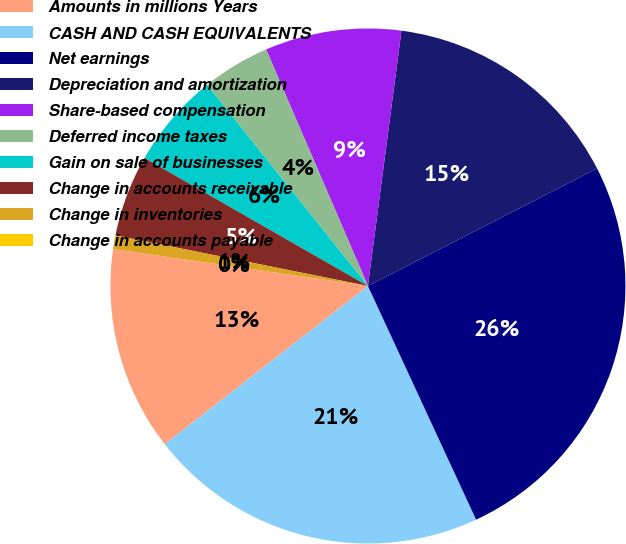Convert chart to OTSL. <chart><loc_0><loc_0><loc_500><loc_500><pie_chart><fcel>Amounts in millions Years<fcel>CASH AND CASH EQUIVALENTS<fcel>Net earnings<fcel>Depreciation and amortization<fcel>Share-based compensation<fcel>Deferred income taxes<fcel>Gain on sale of businesses<fcel>Change in accounts receivable<fcel>Change in inventories<fcel>Change in accounts payable<nl><fcel>12.82%<fcel>21.37%<fcel>25.64%<fcel>15.38%<fcel>8.55%<fcel>4.27%<fcel>5.98%<fcel>5.13%<fcel>0.86%<fcel>0.0%<nl></chart> 